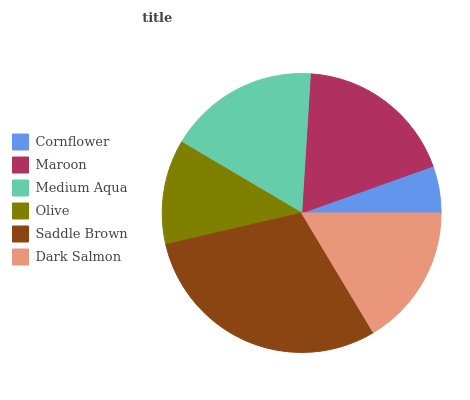Is Cornflower the minimum?
Answer yes or no. Yes. Is Saddle Brown the maximum?
Answer yes or no. Yes. Is Maroon the minimum?
Answer yes or no. No. Is Maroon the maximum?
Answer yes or no. No. Is Maroon greater than Cornflower?
Answer yes or no. Yes. Is Cornflower less than Maroon?
Answer yes or no. Yes. Is Cornflower greater than Maroon?
Answer yes or no. No. Is Maroon less than Cornflower?
Answer yes or no. No. Is Medium Aqua the high median?
Answer yes or no. Yes. Is Dark Salmon the low median?
Answer yes or no. Yes. Is Saddle Brown the high median?
Answer yes or no. No. Is Saddle Brown the low median?
Answer yes or no. No. 